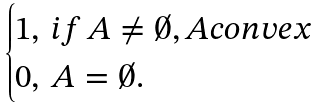<formula> <loc_0><loc_0><loc_500><loc_500>\begin{cases} 1 , \, i f \, A \ne \emptyset , A c o n v e x \\ 0 , \, A = \emptyset . \end{cases}</formula> 